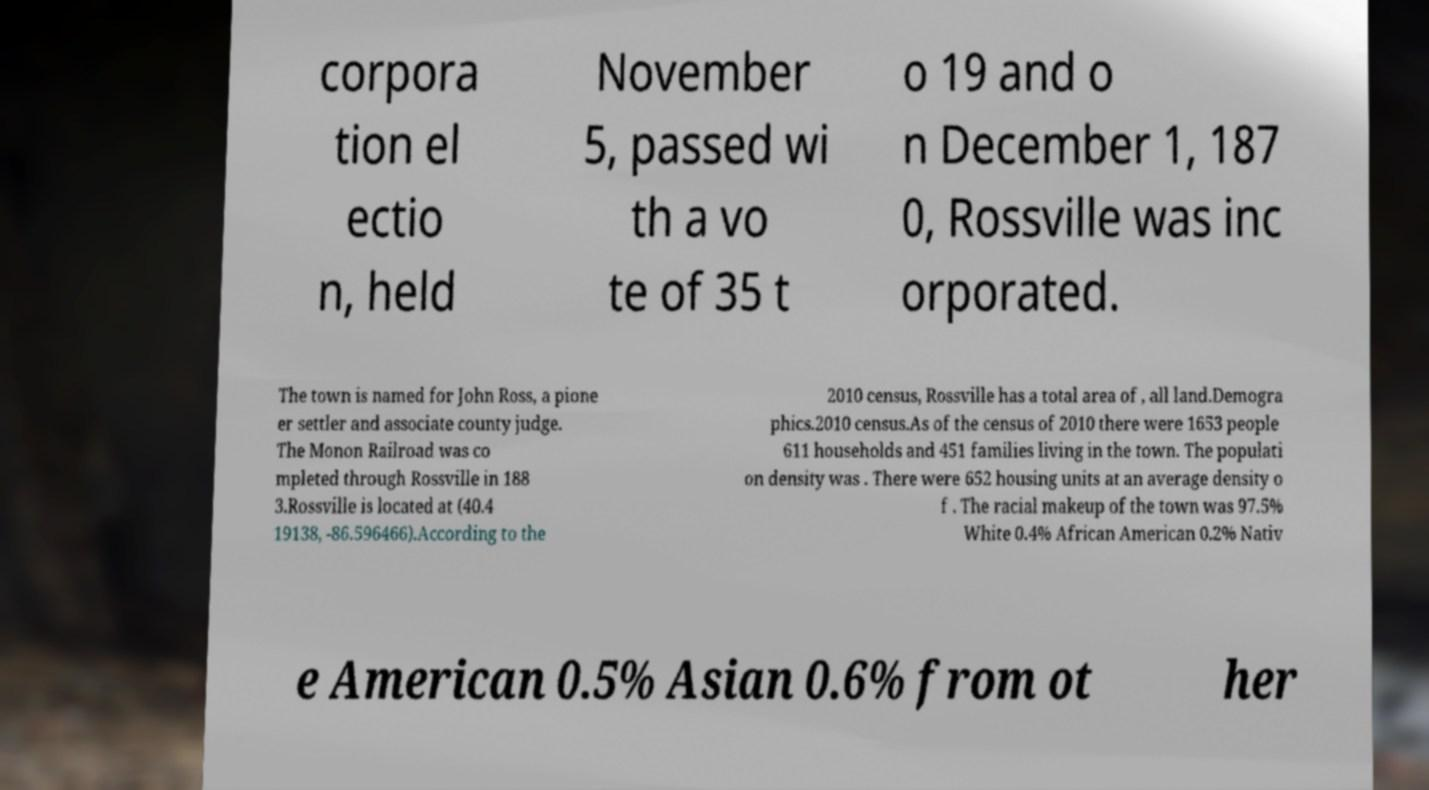I need the written content from this picture converted into text. Can you do that? corpora tion el ectio n, held November 5, passed wi th a vo te of 35 t o 19 and o n December 1, 187 0, Rossville was inc orporated. The town is named for John Ross, a pione er settler and associate county judge. The Monon Railroad was co mpleted through Rossville in 188 3.Rossville is located at (40.4 19138, -86.596466).According to the 2010 census, Rossville has a total area of , all land.Demogra phics.2010 census.As of the census of 2010 there were 1653 people 611 households and 451 families living in the town. The populati on density was . There were 652 housing units at an average density o f . The racial makeup of the town was 97.5% White 0.4% African American 0.2% Nativ e American 0.5% Asian 0.6% from ot her 